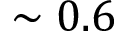<formula> <loc_0><loc_0><loc_500><loc_500>\sim 0 . 6</formula> 